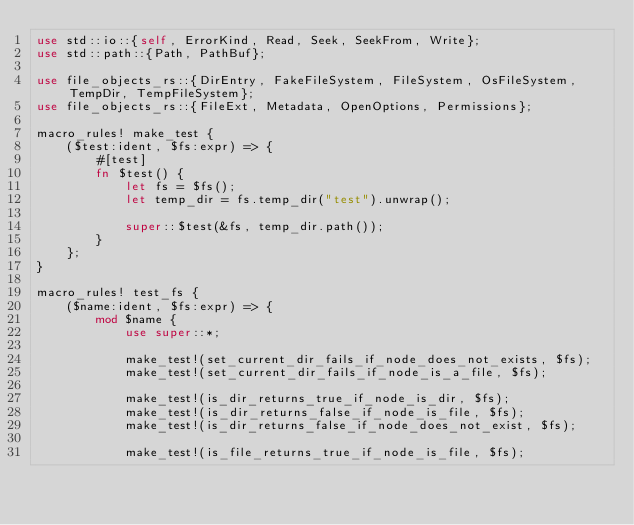<code> <loc_0><loc_0><loc_500><loc_500><_Rust_>use std::io::{self, ErrorKind, Read, Seek, SeekFrom, Write};
use std::path::{Path, PathBuf};

use file_objects_rs::{DirEntry, FakeFileSystem, FileSystem, OsFileSystem, TempDir, TempFileSystem};
use file_objects_rs::{FileExt, Metadata, OpenOptions, Permissions};

macro_rules! make_test {
    ($test:ident, $fs:expr) => {
        #[test]
        fn $test() {
            let fs = $fs();
            let temp_dir = fs.temp_dir("test").unwrap();

            super::$test(&fs, temp_dir.path());
        }
    };
}

macro_rules! test_fs {
    ($name:ident, $fs:expr) => {
        mod $name {
            use super::*;

            make_test!(set_current_dir_fails_if_node_does_not_exists, $fs);
            make_test!(set_current_dir_fails_if_node_is_a_file, $fs);

            make_test!(is_dir_returns_true_if_node_is_dir, $fs);
            make_test!(is_dir_returns_false_if_node_is_file, $fs);
            make_test!(is_dir_returns_false_if_node_does_not_exist, $fs);

            make_test!(is_file_returns_true_if_node_is_file, $fs);</code> 